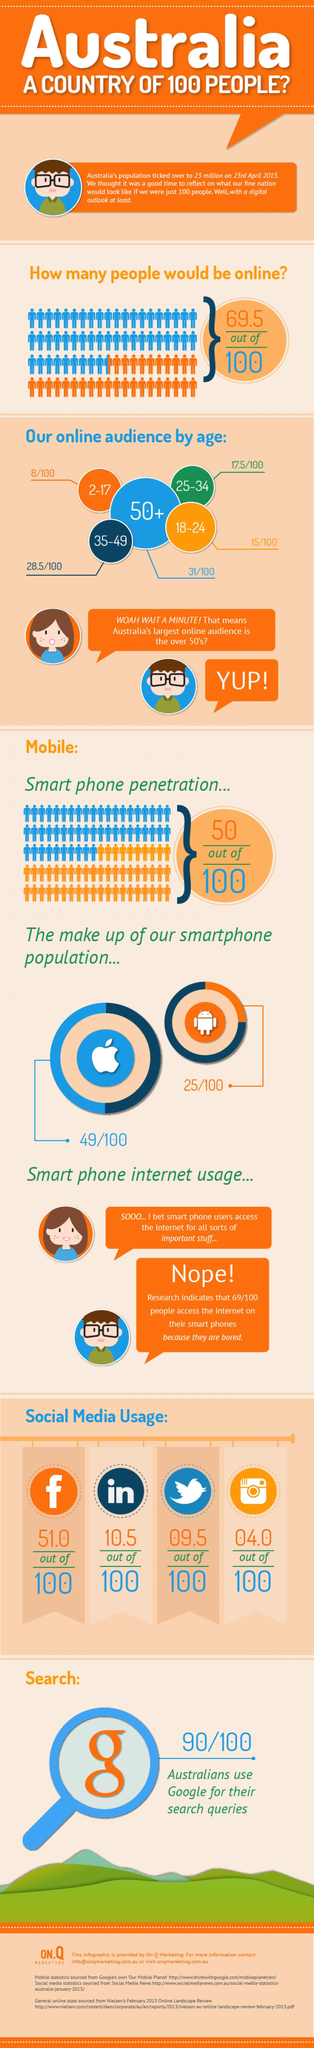How many people in 100 use android phones?
Answer the question with a short phrase. 25 Which age group has smallest number of online users? 2-17 Out of 100, how many people use Instagram? 04.0 How many people in 100 use Facebook? 51.0 28.5/100 of online audience belongs to which age group? 35-49 Out of 100, how many people use LinkedIn? 10.5 31 out of 100 of online audience are in which age group? 50+ How many people in 100 use twitter? 9.5 17.5 out of 100 online users are in which age group? 25-34 How many people in 100 use iphones? 49 